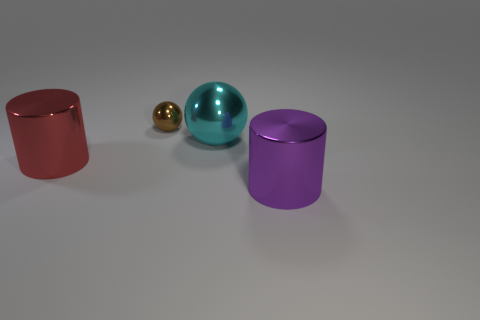Is the small shiny object the same color as the big metallic ball?
Give a very brief answer. No. There is a big cyan thing that is on the left side of the purple metallic object; is it the same shape as the big purple object?
Provide a succinct answer. No. What number of balls have the same size as the red object?
Your answer should be very brief. 1. Is there a shiny cylinder in front of the thing that is in front of the big red object?
Offer a terse response. No. What number of things are cylinders right of the tiny sphere or big cylinders?
Your answer should be compact. 2. What number of big spheres are there?
Your answer should be very brief. 1. What is the shape of the red thing that is the same material as the brown sphere?
Give a very brief answer. Cylinder. There is a cylinder behind the big thing that is in front of the big red object; what size is it?
Provide a short and direct response. Large. How many objects are metal cylinders in front of the big red cylinder or large shiny cylinders that are behind the big purple metal cylinder?
Your answer should be compact. 2. Is the number of purple things less than the number of large purple matte blocks?
Keep it short and to the point. No. 